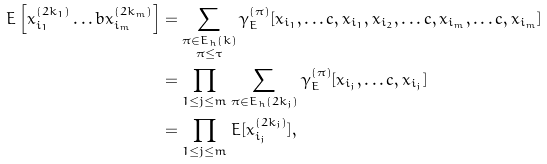Convert formula to latex. <formula><loc_0><loc_0><loc_500><loc_500>E \left [ x _ { i _ { 1 } } ^ { ( 2 k _ { 1 } ) } \dots b x _ { i _ { m } } ^ { ( 2 k _ { m } ) } \right ] & = \sum _ { \substack { \pi \in E _ { h } ( k ) \\ \pi \leq \tau } } \gamma _ { E } ^ { ( \pi ) } [ x _ { i _ { 1 } } , \dots c , x _ { i _ { 1 } } , x _ { i _ { 2 } } , \dots c , x _ { i _ { m } } , \dots c , x _ { i _ { m } } ] \\ & = \prod _ { 1 \leq j \leq m } \sum _ { \substack { \pi \in E _ { h } ( 2 k _ { j } ) } } \gamma _ { E } ^ { ( \pi ) } [ x _ { i _ { j } } , \dots c , x _ { i _ { j } } ] \\ & = \prod _ { 1 \leq j \leq m } E [ x _ { i _ { j } } ^ { ( 2 k _ { j } ) } ] ,</formula> 